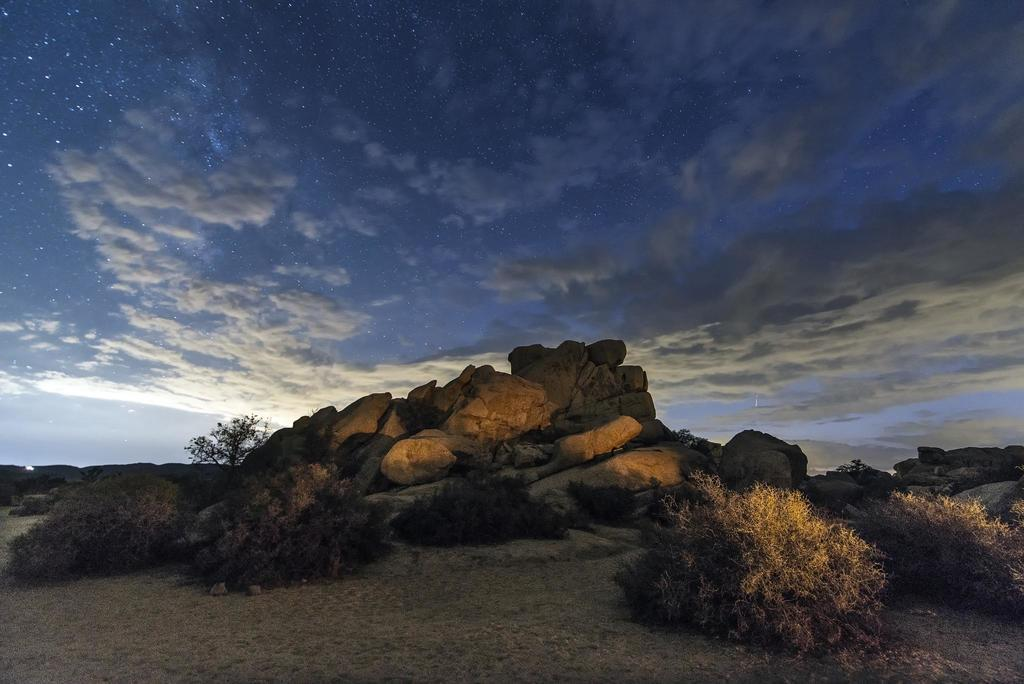What type of vegetation can be seen in the image? There are plants in the image. What type of terrain is visible in the image? There is sand and rocks in the image. What can be seen in the background of the image? There are trees and the sky in the background of the image. What celestial bodies are visible in the sky in the background of the image? Stars are visible in the sky in the background of the image. What type of weather can be inferred from the image? Clouds are present in the sky in the background of the image, suggesting that it might be a partly cloudy day. What type of operation is being performed by the existence in the image? There is no "existence" present in the image; it is a landscape featuring plants, sand, rocks, trees, stars, and clouds. How can one join the group of clouds in the image? The clouds in the image are not a group that one can join; they are a natural atmospheric phenomenon. 